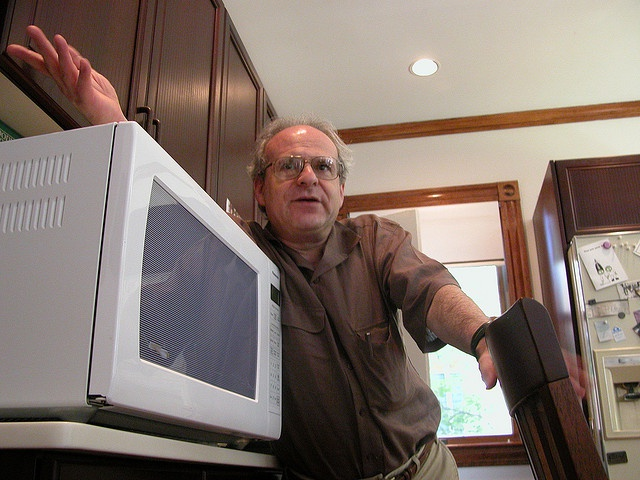Describe the objects in this image and their specific colors. I can see microwave in black, darkgray, gray, and lightgray tones, people in black, maroon, and brown tones, refrigerator in black, darkgray, maroon, and gray tones, and chair in black, maroon, purple, and gray tones in this image. 